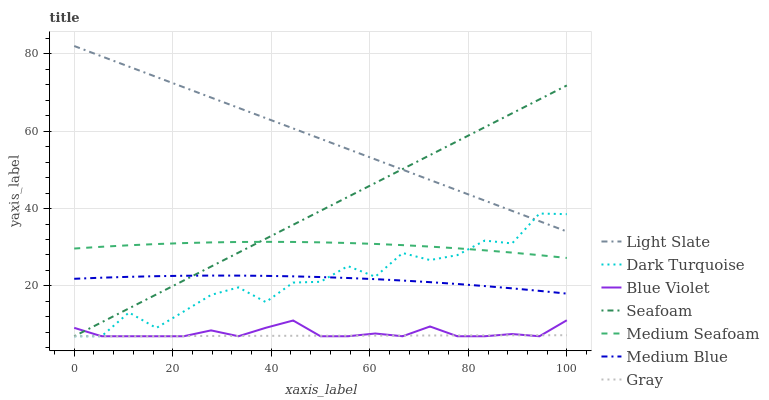Does Gray have the minimum area under the curve?
Answer yes or no. Yes. Does Light Slate have the maximum area under the curve?
Answer yes or no. Yes. Does Dark Turquoise have the minimum area under the curve?
Answer yes or no. No. Does Dark Turquoise have the maximum area under the curve?
Answer yes or no. No. Is Gray the smoothest?
Answer yes or no. Yes. Is Dark Turquoise the roughest?
Answer yes or no. Yes. Is Light Slate the smoothest?
Answer yes or no. No. Is Light Slate the roughest?
Answer yes or no. No. Does Gray have the lowest value?
Answer yes or no. Yes. Does Light Slate have the lowest value?
Answer yes or no. No. Does Light Slate have the highest value?
Answer yes or no. Yes. Does Dark Turquoise have the highest value?
Answer yes or no. No. Is Gray less than Medium Seafoam?
Answer yes or no. Yes. Is Medium Seafoam greater than Gray?
Answer yes or no. Yes. Does Blue Violet intersect Dark Turquoise?
Answer yes or no. Yes. Is Blue Violet less than Dark Turquoise?
Answer yes or no. No. Is Blue Violet greater than Dark Turquoise?
Answer yes or no. No. Does Gray intersect Medium Seafoam?
Answer yes or no. No. 